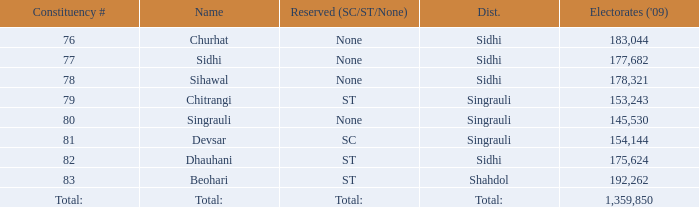Can you parse all the data within this table? {'header': ['Constituency #', 'Name', 'Reserved (SC/ST/None)', 'Dist.', "Electorates ('09)"], 'rows': [['76', 'Churhat', 'None', 'Sidhi', '183,044'], ['77', 'Sidhi', 'None', 'Sidhi', '177,682'], ['78', 'Sihawal', 'None', 'Sidhi', '178,321'], ['79', 'Chitrangi', 'ST', 'Singrauli', '153,243'], ['80', 'Singrauli', 'None', 'Singrauli', '145,530'], ['81', 'Devsar', 'SC', 'Singrauli', '154,144'], ['82', 'Dhauhani', 'ST', 'Sidhi', '175,624'], ['83', 'Beohari', 'ST', 'Shahdol', '192,262'], ['Total:', 'Total:', 'Total:', 'Total:', '1,359,850']]} What is Beohari's highest number of electorates? 192262.0. 